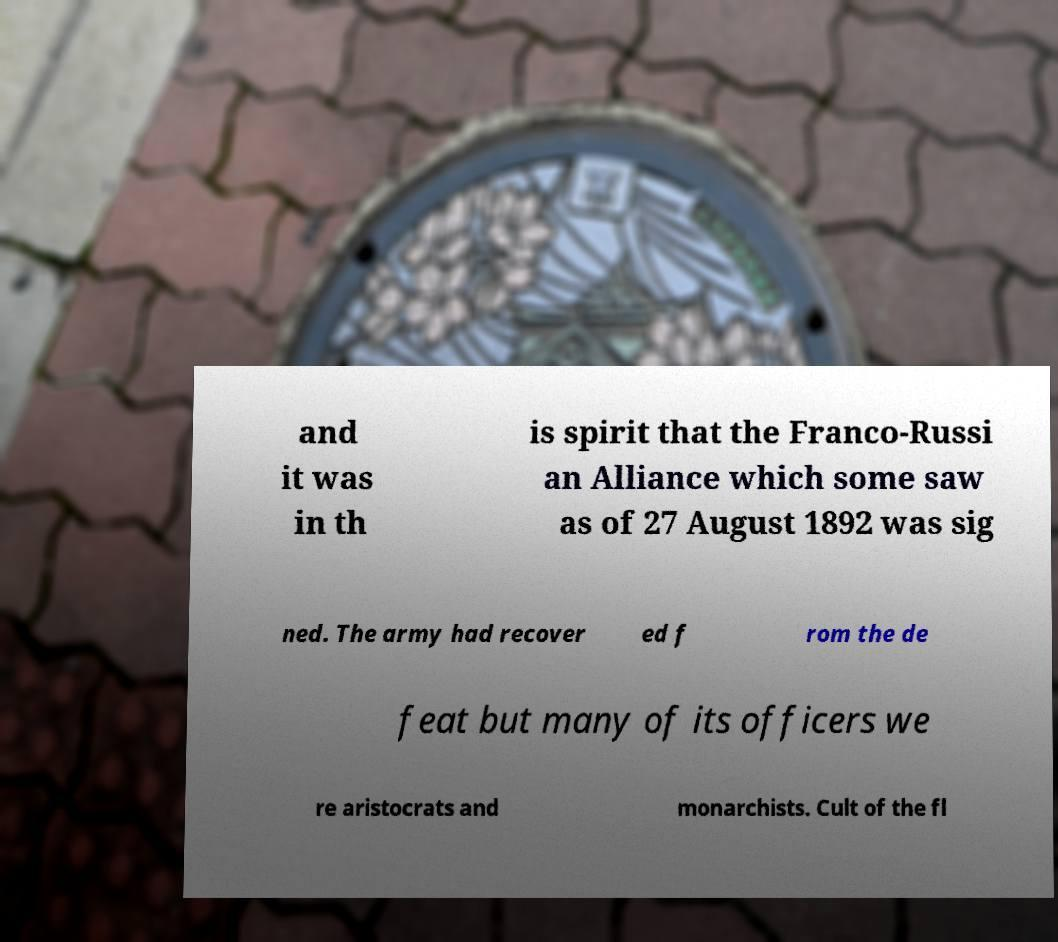Can you accurately transcribe the text from the provided image for me? and it was in th is spirit that the Franco-Russi an Alliance which some saw as of 27 August 1892 was sig ned. The army had recover ed f rom the de feat but many of its officers we re aristocrats and monarchists. Cult of the fl 